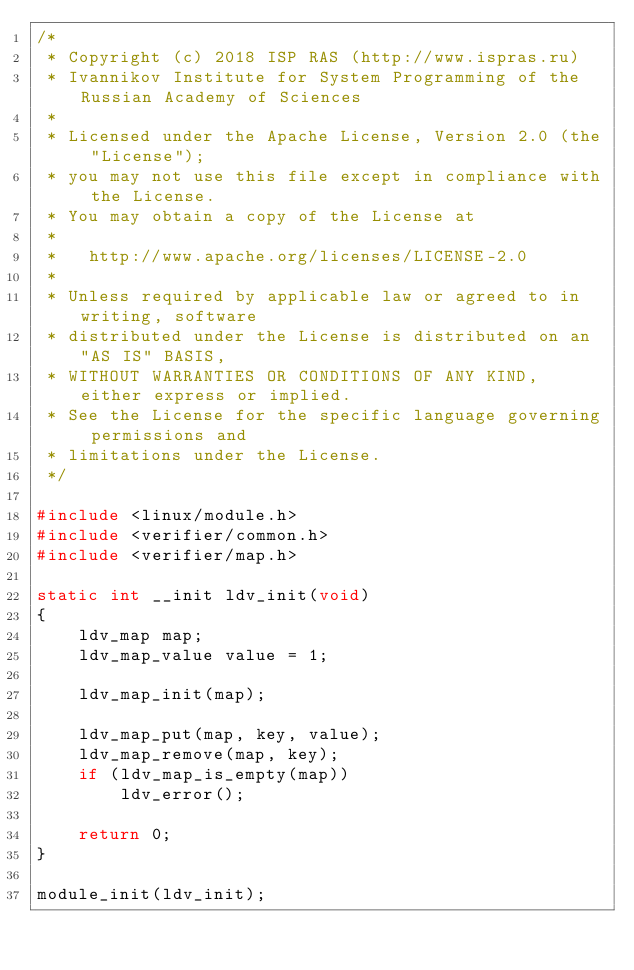<code> <loc_0><loc_0><loc_500><loc_500><_C_>/*
 * Copyright (c) 2018 ISP RAS (http://www.ispras.ru)
 * Ivannikov Institute for System Programming of the Russian Academy of Sciences
 *
 * Licensed under the Apache License, Version 2.0 (the "License");
 * you may not use this file except in compliance with the License.
 * You may obtain a copy of the License at
 *
 *   http://www.apache.org/licenses/LICENSE-2.0
 *
 * Unless required by applicable law or agreed to in writing, software
 * distributed under the License is distributed on an "AS IS" BASIS,
 * WITHOUT WARRANTIES OR CONDITIONS OF ANY KIND, either express or implied.
 * See the License for the specific language governing permissions and
 * limitations under the License.
 */

#include <linux/module.h>
#include <verifier/common.h>
#include <verifier/map.h>

static int __init ldv_init(void)
{
	ldv_map map;
	ldv_map_value value = 1;

	ldv_map_init(map);

	ldv_map_put(map, key, value);
	ldv_map_remove(map, key);
	if (ldv_map_is_empty(map))
		ldv_error();

	return 0;
}

module_init(ldv_init);
</code> 